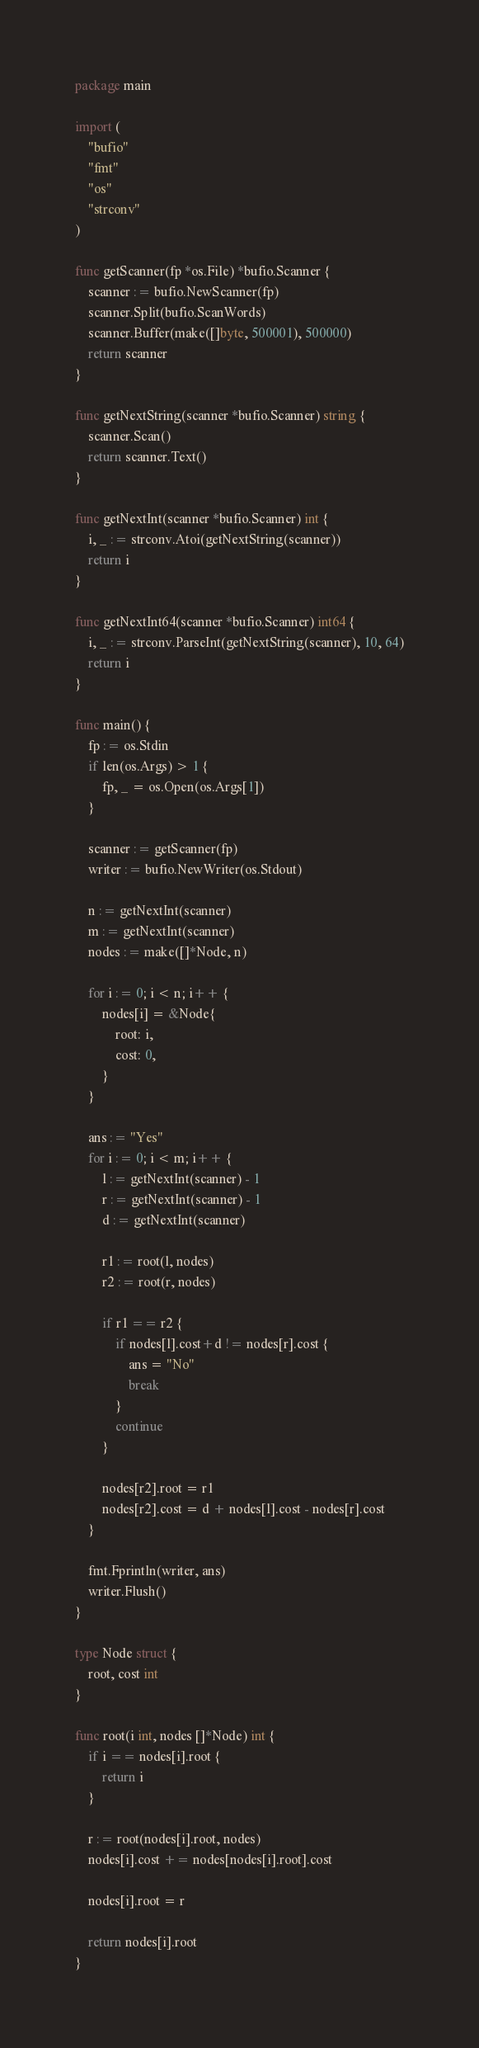<code> <loc_0><loc_0><loc_500><loc_500><_Go_>package main

import (
	"bufio"
	"fmt"
	"os"
	"strconv"
)

func getScanner(fp *os.File) *bufio.Scanner {
	scanner := bufio.NewScanner(fp)
	scanner.Split(bufio.ScanWords)
	scanner.Buffer(make([]byte, 500001), 500000)
	return scanner
}

func getNextString(scanner *bufio.Scanner) string {
	scanner.Scan()
	return scanner.Text()
}

func getNextInt(scanner *bufio.Scanner) int {
	i, _ := strconv.Atoi(getNextString(scanner))
	return i
}

func getNextInt64(scanner *bufio.Scanner) int64 {
	i, _ := strconv.ParseInt(getNextString(scanner), 10, 64)
	return i
}

func main() {
	fp := os.Stdin
	if len(os.Args) > 1 {
		fp, _ = os.Open(os.Args[1])
	}

	scanner := getScanner(fp)
	writer := bufio.NewWriter(os.Stdout)

	n := getNextInt(scanner)
	m := getNextInt(scanner)
	nodes := make([]*Node, n)

	for i := 0; i < n; i++ {
		nodes[i] = &Node{
			root: i,
			cost: 0,
		}
	}

	ans := "Yes"
	for i := 0; i < m; i++ {
		l := getNextInt(scanner) - 1
		r := getNextInt(scanner) - 1
		d := getNextInt(scanner)

		r1 := root(l, nodes)
		r2 := root(r, nodes)

		if r1 == r2 {
			if nodes[l].cost+d != nodes[r].cost {
				ans = "No"
				break
			}
			continue
		}

		nodes[r2].root = r1
		nodes[r2].cost = d + nodes[l].cost - nodes[r].cost
	}

	fmt.Fprintln(writer, ans)
	writer.Flush()
}

type Node struct {
	root, cost int
}

func root(i int, nodes []*Node) int {
	if i == nodes[i].root {
		return i
	}

	r := root(nodes[i].root, nodes)
	nodes[i].cost += nodes[nodes[i].root].cost

	nodes[i].root = r

	return nodes[i].root
}
</code> 